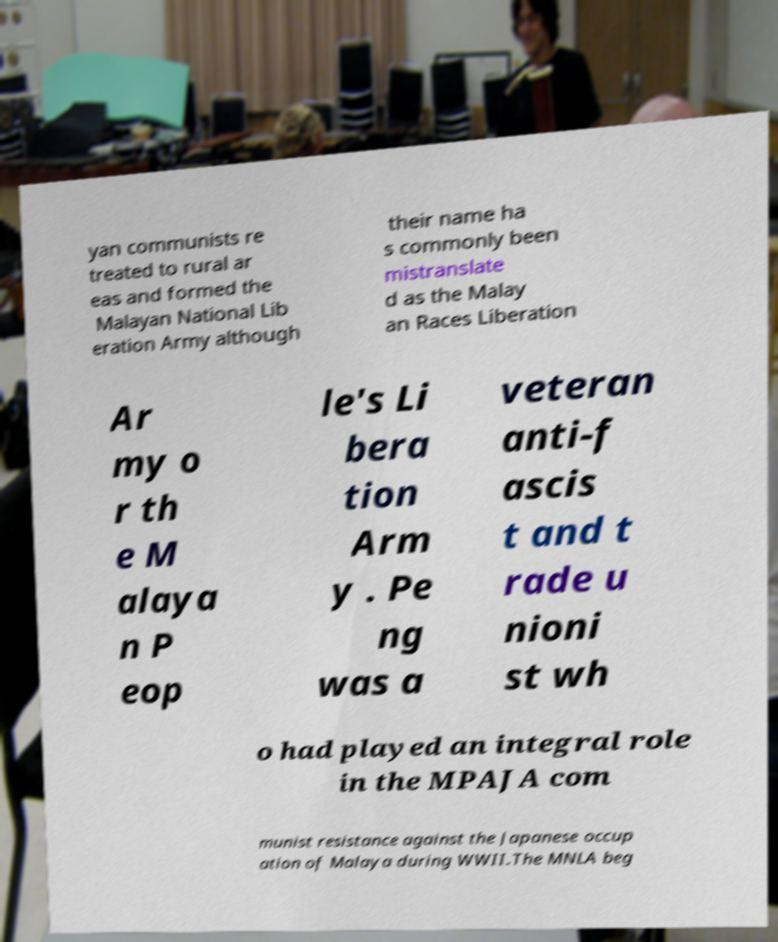Can you read and provide the text displayed in the image?This photo seems to have some interesting text. Can you extract and type it out for me? yan communists re treated to rural ar eas and formed the Malayan National Lib eration Army although their name ha s commonly been mistranslate d as the Malay an Races Liberation Ar my o r th e M alaya n P eop le's Li bera tion Arm y . Pe ng was a veteran anti-f ascis t and t rade u nioni st wh o had played an integral role in the MPAJA com munist resistance against the Japanese occup ation of Malaya during WWII.The MNLA beg 